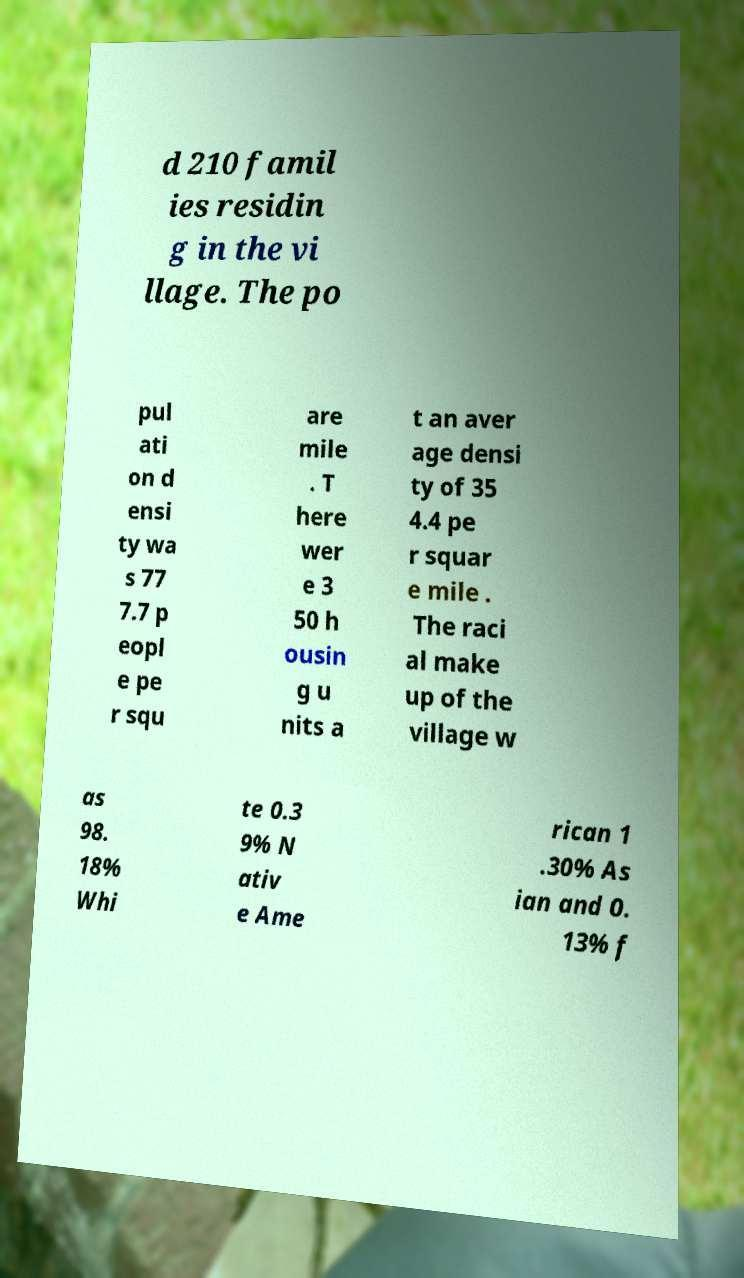Can you read and provide the text displayed in the image?This photo seems to have some interesting text. Can you extract and type it out for me? d 210 famil ies residin g in the vi llage. The po pul ati on d ensi ty wa s 77 7.7 p eopl e pe r squ are mile . T here wer e 3 50 h ousin g u nits a t an aver age densi ty of 35 4.4 pe r squar e mile . The raci al make up of the village w as 98. 18% Whi te 0.3 9% N ativ e Ame rican 1 .30% As ian and 0. 13% f 